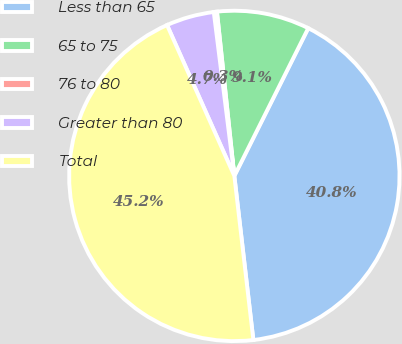Convert chart to OTSL. <chart><loc_0><loc_0><loc_500><loc_500><pie_chart><fcel>Less than 65<fcel>65 to 75<fcel>76 to 80<fcel>Greater than 80<fcel>Total<nl><fcel>40.78%<fcel>9.06%<fcel>0.31%<fcel>4.69%<fcel>45.16%<nl></chart> 